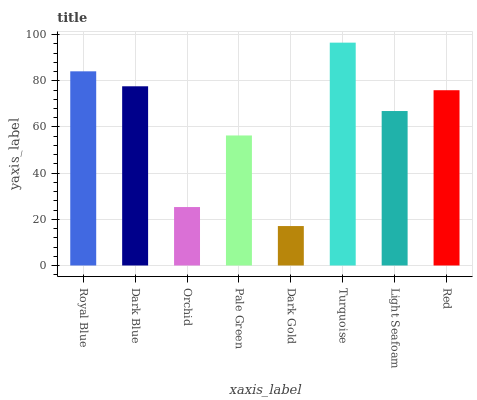Is Dark Gold the minimum?
Answer yes or no. Yes. Is Turquoise the maximum?
Answer yes or no. Yes. Is Dark Blue the minimum?
Answer yes or no. No. Is Dark Blue the maximum?
Answer yes or no. No. Is Royal Blue greater than Dark Blue?
Answer yes or no. Yes. Is Dark Blue less than Royal Blue?
Answer yes or no. Yes. Is Dark Blue greater than Royal Blue?
Answer yes or no. No. Is Royal Blue less than Dark Blue?
Answer yes or no. No. Is Red the high median?
Answer yes or no. Yes. Is Light Seafoam the low median?
Answer yes or no. Yes. Is Dark Blue the high median?
Answer yes or no. No. Is Royal Blue the low median?
Answer yes or no. No. 